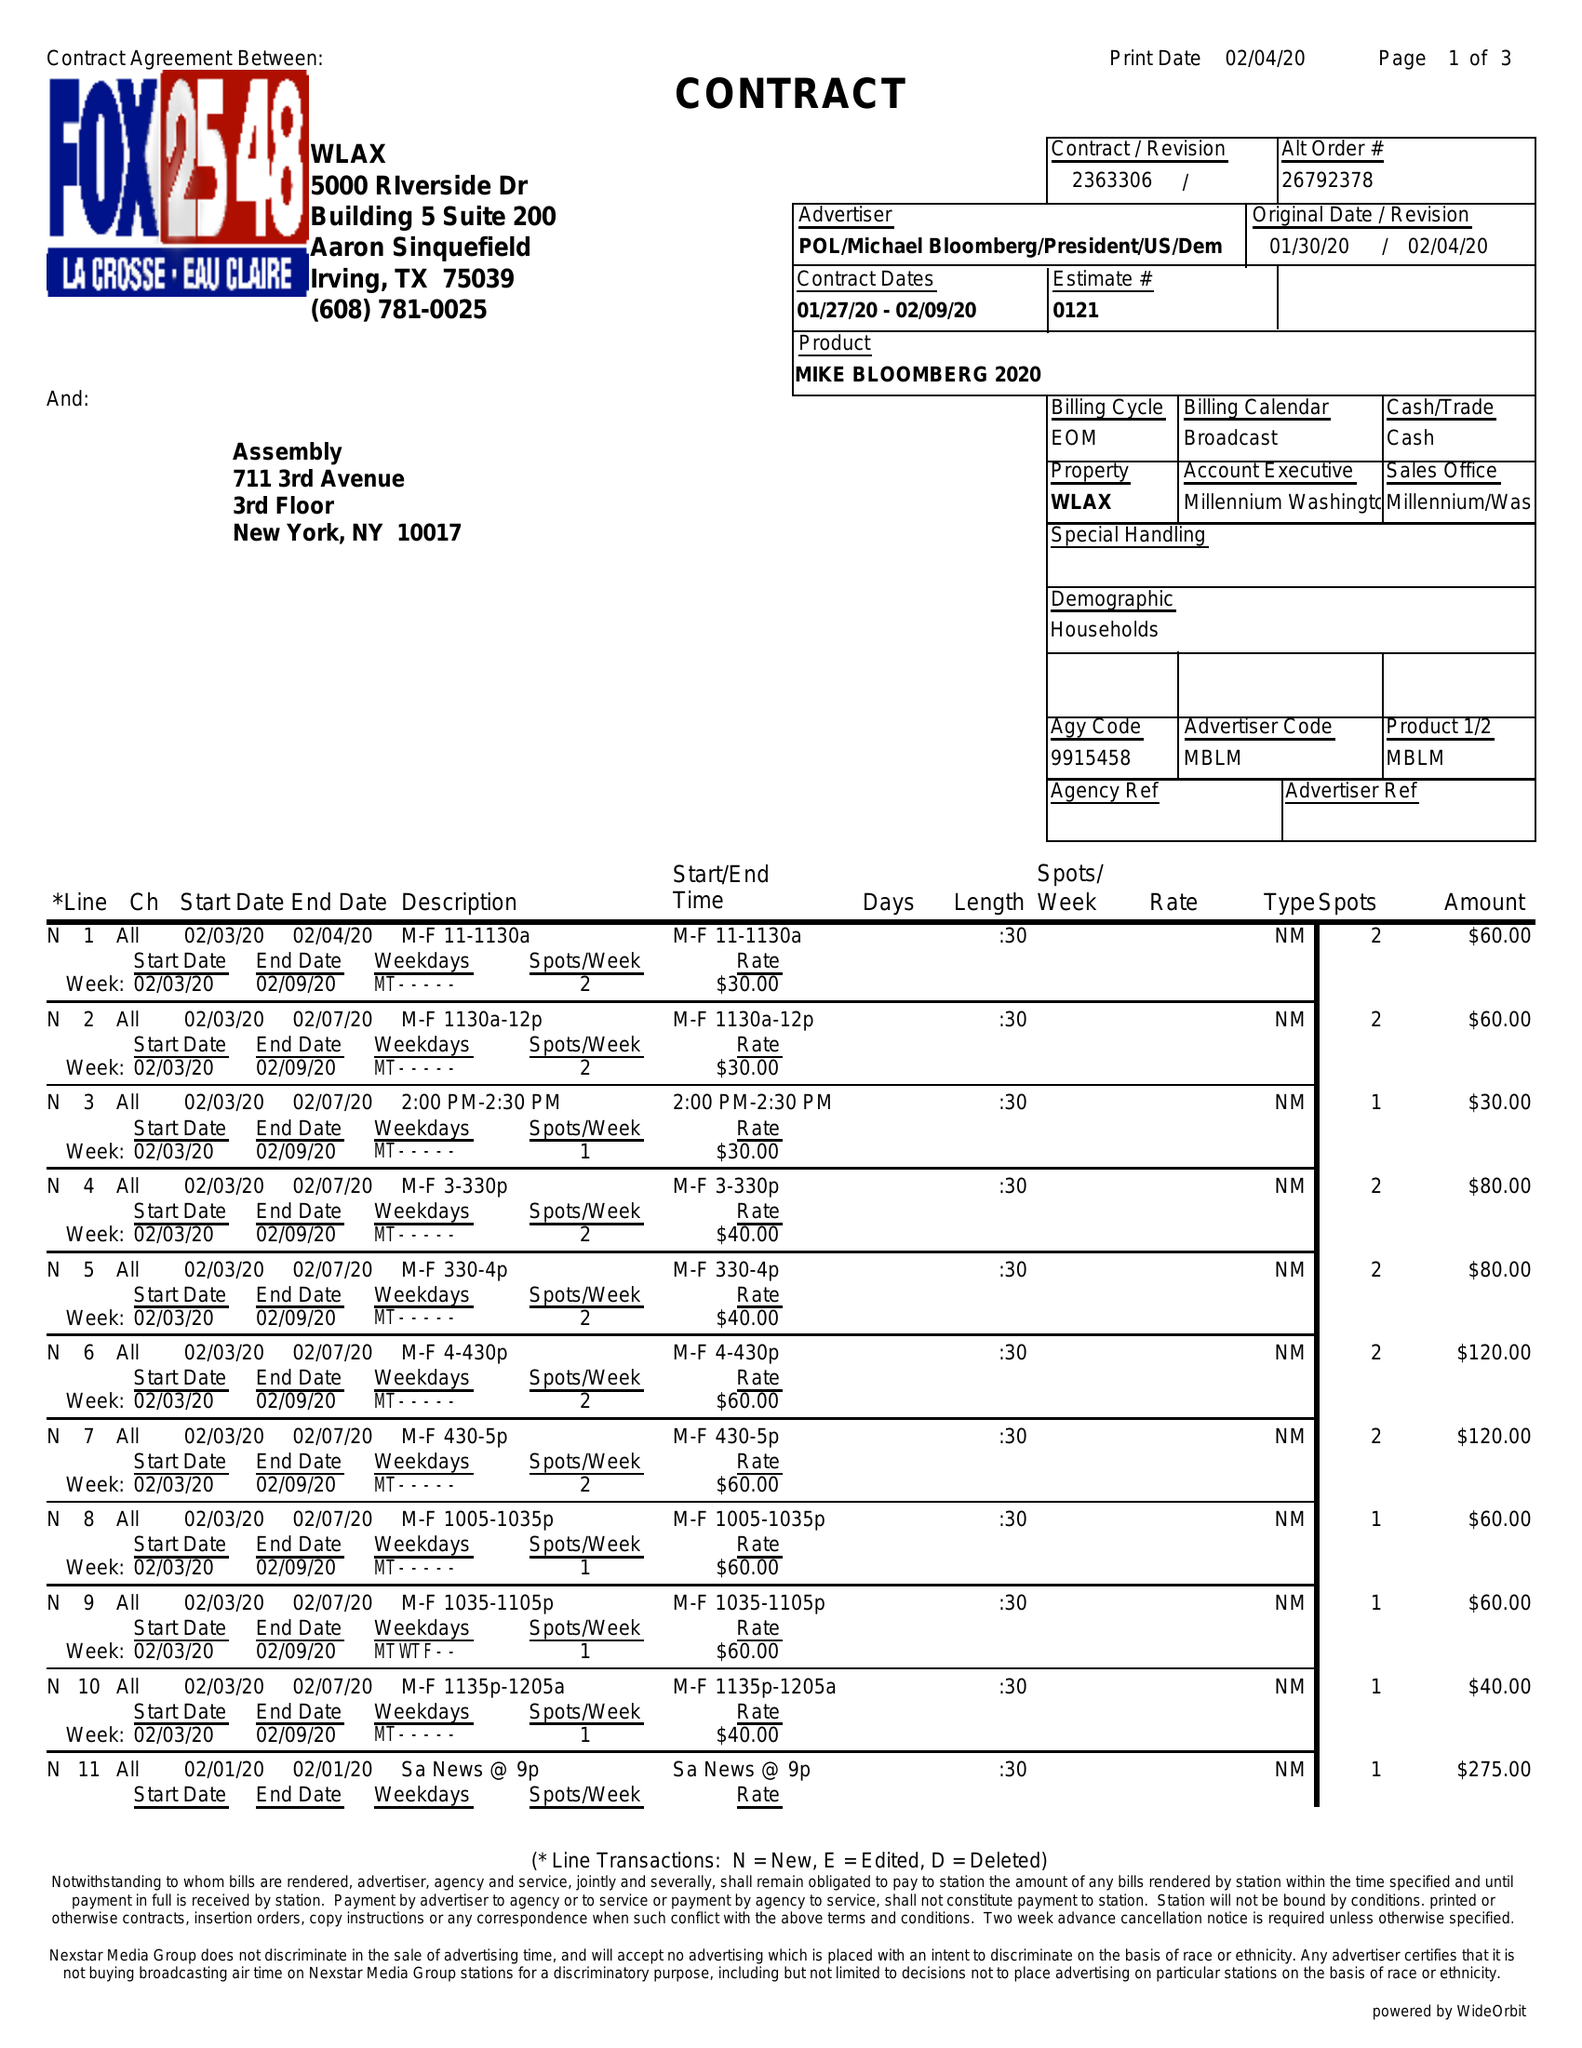What is the value for the advertiser?
Answer the question using a single word or phrase. POL/MICHAELBLOOMBERG/PRESIDENT/US/DEM 